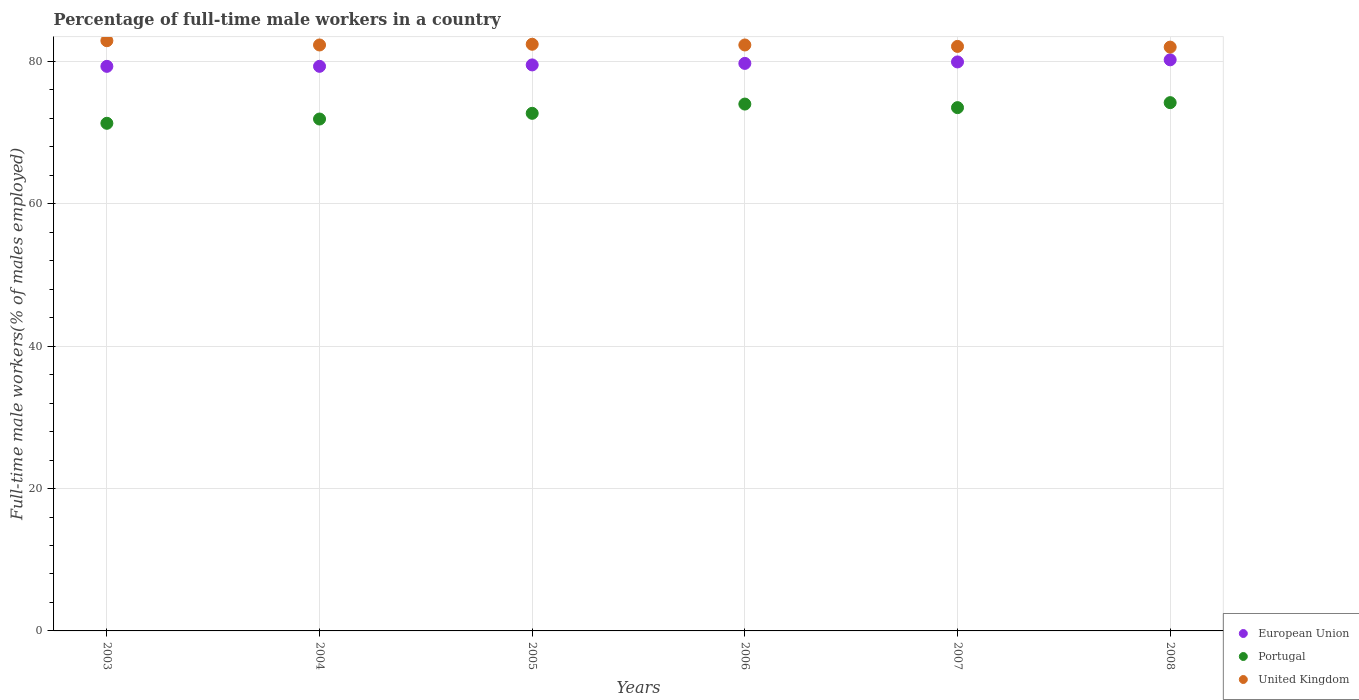What is the percentage of full-time male workers in European Union in 2006?
Give a very brief answer. 79.71. Across all years, what is the maximum percentage of full-time male workers in United Kingdom?
Your answer should be very brief. 82.9. Across all years, what is the minimum percentage of full-time male workers in European Union?
Give a very brief answer. 79.3. In which year was the percentage of full-time male workers in United Kingdom maximum?
Give a very brief answer. 2003. In which year was the percentage of full-time male workers in Portugal minimum?
Your response must be concise. 2003. What is the total percentage of full-time male workers in United Kingdom in the graph?
Provide a short and direct response. 494. What is the difference between the percentage of full-time male workers in United Kingdom in 2003 and that in 2006?
Ensure brevity in your answer.  0.6. What is the difference between the percentage of full-time male workers in United Kingdom in 2006 and the percentage of full-time male workers in Portugal in 2005?
Make the answer very short. 9.6. What is the average percentage of full-time male workers in European Union per year?
Keep it short and to the point. 79.66. In the year 2008, what is the difference between the percentage of full-time male workers in Portugal and percentage of full-time male workers in European Union?
Ensure brevity in your answer.  -6.01. What is the ratio of the percentage of full-time male workers in United Kingdom in 2005 to that in 2008?
Provide a short and direct response. 1. Is the percentage of full-time male workers in United Kingdom in 2003 less than that in 2005?
Your response must be concise. No. What is the difference between the highest and the second highest percentage of full-time male workers in United Kingdom?
Your response must be concise. 0.5. What is the difference between the highest and the lowest percentage of full-time male workers in United Kingdom?
Your answer should be compact. 0.9. In how many years, is the percentage of full-time male workers in European Union greater than the average percentage of full-time male workers in European Union taken over all years?
Offer a very short reply. 3. Is it the case that in every year, the sum of the percentage of full-time male workers in United Kingdom and percentage of full-time male workers in Portugal  is greater than the percentage of full-time male workers in European Union?
Make the answer very short. Yes. Does the percentage of full-time male workers in United Kingdom monotonically increase over the years?
Your answer should be compact. No. Is the percentage of full-time male workers in European Union strictly less than the percentage of full-time male workers in United Kingdom over the years?
Provide a succinct answer. Yes. How many dotlines are there?
Your response must be concise. 3. Where does the legend appear in the graph?
Keep it short and to the point. Bottom right. What is the title of the graph?
Your answer should be very brief. Percentage of full-time male workers in a country. Does "High income: OECD" appear as one of the legend labels in the graph?
Ensure brevity in your answer.  No. What is the label or title of the Y-axis?
Provide a succinct answer. Full-time male workers(% of males employed). What is the Full-time male workers(% of males employed) of European Union in 2003?
Offer a very short reply. 79.3. What is the Full-time male workers(% of males employed) in Portugal in 2003?
Give a very brief answer. 71.3. What is the Full-time male workers(% of males employed) in United Kingdom in 2003?
Ensure brevity in your answer.  82.9. What is the Full-time male workers(% of males employed) of European Union in 2004?
Offer a terse response. 79.3. What is the Full-time male workers(% of males employed) in Portugal in 2004?
Make the answer very short. 71.9. What is the Full-time male workers(% of males employed) of United Kingdom in 2004?
Provide a succinct answer. 82.3. What is the Full-time male workers(% of males employed) in European Union in 2005?
Ensure brevity in your answer.  79.5. What is the Full-time male workers(% of males employed) of Portugal in 2005?
Give a very brief answer. 72.7. What is the Full-time male workers(% of males employed) of United Kingdom in 2005?
Your answer should be compact. 82.4. What is the Full-time male workers(% of males employed) of European Union in 2006?
Keep it short and to the point. 79.71. What is the Full-time male workers(% of males employed) in United Kingdom in 2006?
Give a very brief answer. 82.3. What is the Full-time male workers(% of males employed) in European Union in 2007?
Keep it short and to the point. 79.92. What is the Full-time male workers(% of males employed) in Portugal in 2007?
Offer a terse response. 73.5. What is the Full-time male workers(% of males employed) in United Kingdom in 2007?
Provide a short and direct response. 82.1. What is the Full-time male workers(% of males employed) of European Union in 2008?
Your answer should be compact. 80.21. What is the Full-time male workers(% of males employed) of Portugal in 2008?
Your answer should be compact. 74.2. Across all years, what is the maximum Full-time male workers(% of males employed) in European Union?
Your answer should be compact. 80.21. Across all years, what is the maximum Full-time male workers(% of males employed) in Portugal?
Give a very brief answer. 74.2. Across all years, what is the maximum Full-time male workers(% of males employed) of United Kingdom?
Your answer should be compact. 82.9. Across all years, what is the minimum Full-time male workers(% of males employed) of European Union?
Your answer should be compact. 79.3. Across all years, what is the minimum Full-time male workers(% of males employed) in Portugal?
Ensure brevity in your answer.  71.3. What is the total Full-time male workers(% of males employed) of European Union in the graph?
Provide a succinct answer. 477.94. What is the total Full-time male workers(% of males employed) of Portugal in the graph?
Offer a very short reply. 437.6. What is the total Full-time male workers(% of males employed) of United Kingdom in the graph?
Offer a very short reply. 494. What is the difference between the Full-time male workers(% of males employed) in European Union in 2003 and that in 2004?
Ensure brevity in your answer.  -0. What is the difference between the Full-time male workers(% of males employed) in United Kingdom in 2003 and that in 2004?
Provide a succinct answer. 0.6. What is the difference between the Full-time male workers(% of males employed) of European Union in 2003 and that in 2005?
Your answer should be very brief. -0.2. What is the difference between the Full-time male workers(% of males employed) of European Union in 2003 and that in 2006?
Your answer should be very brief. -0.41. What is the difference between the Full-time male workers(% of males employed) of United Kingdom in 2003 and that in 2006?
Your answer should be very brief. 0.6. What is the difference between the Full-time male workers(% of males employed) in European Union in 2003 and that in 2007?
Keep it short and to the point. -0.62. What is the difference between the Full-time male workers(% of males employed) of Portugal in 2003 and that in 2007?
Offer a terse response. -2.2. What is the difference between the Full-time male workers(% of males employed) in European Union in 2003 and that in 2008?
Give a very brief answer. -0.92. What is the difference between the Full-time male workers(% of males employed) in United Kingdom in 2003 and that in 2008?
Keep it short and to the point. 0.9. What is the difference between the Full-time male workers(% of males employed) of European Union in 2004 and that in 2005?
Provide a short and direct response. -0.2. What is the difference between the Full-time male workers(% of males employed) of Portugal in 2004 and that in 2005?
Ensure brevity in your answer.  -0.8. What is the difference between the Full-time male workers(% of males employed) of United Kingdom in 2004 and that in 2005?
Provide a succinct answer. -0.1. What is the difference between the Full-time male workers(% of males employed) of European Union in 2004 and that in 2006?
Provide a succinct answer. -0.41. What is the difference between the Full-time male workers(% of males employed) in European Union in 2004 and that in 2007?
Offer a very short reply. -0.62. What is the difference between the Full-time male workers(% of males employed) in European Union in 2004 and that in 2008?
Provide a short and direct response. -0.91. What is the difference between the Full-time male workers(% of males employed) in European Union in 2005 and that in 2006?
Make the answer very short. -0.21. What is the difference between the Full-time male workers(% of males employed) in United Kingdom in 2005 and that in 2006?
Ensure brevity in your answer.  0.1. What is the difference between the Full-time male workers(% of males employed) of European Union in 2005 and that in 2007?
Give a very brief answer. -0.42. What is the difference between the Full-time male workers(% of males employed) of Portugal in 2005 and that in 2007?
Give a very brief answer. -0.8. What is the difference between the Full-time male workers(% of males employed) of European Union in 2005 and that in 2008?
Give a very brief answer. -0.71. What is the difference between the Full-time male workers(% of males employed) in European Union in 2006 and that in 2007?
Your answer should be compact. -0.21. What is the difference between the Full-time male workers(% of males employed) in United Kingdom in 2006 and that in 2007?
Ensure brevity in your answer.  0.2. What is the difference between the Full-time male workers(% of males employed) in European Union in 2006 and that in 2008?
Give a very brief answer. -0.5. What is the difference between the Full-time male workers(% of males employed) in European Union in 2007 and that in 2008?
Keep it short and to the point. -0.3. What is the difference between the Full-time male workers(% of males employed) of Portugal in 2007 and that in 2008?
Keep it short and to the point. -0.7. What is the difference between the Full-time male workers(% of males employed) in United Kingdom in 2007 and that in 2008?
Make the answer very short. 0.1. What is the difference between the Full-time male workers(% of males employed) in European Union in 2003 and the Full-time male workers(% of males employed) in Portugal in 2004?
Provide a short and direct response. 7.4. What is the difference between the Full-time male workers(% of males employed) of European Union in 2003 and the Full-time male workers(% of males employed) of United Kingdom in 2004?
Ensure brevity in your answer.  -3. What is the difference between the Full-time male workers(% of males employed) in Portugal in 2003 and the Full-time male workers(% of males employed) in United Kingdom in 2004?
Your answer should be very brief. -11. What is the difference between the Full-time male workers(% of males employed) of European Union in 2003 and the Full-time male workers(% of males employed) of Portugal in 2005?
Provide a short and direct response. 6.6. What is the difference between the Full-time male workers(% of males employed) of European Union in 2003 and the Full-time male workers(% of males employed) of United Kingdom in 2005?
Offer a very short reply. -3.1. What is the difference between the Full-time male workers(% of males employed) of European Union in 2003 and the Full-time male workers(% of males employed) of Portugal in 2006?
Offer a very short reply. 5.3. What is the difference between the Full-time male workers(% of males employed) in European Union in 2003 and the Full-time male workers(% of males employed) in United Kingdom in 2006?
Keep it short and to the point. -3. What is the difference between the Full-time male workers(% of males employed) of European Union in 2003 and the Full-time male workers(% of males employed) of Portugal in 2007?
Keep it short and to the point. 5.8. What is the difference between the Full-time male workers(% of males employed) in European Union in 2003 and the Full-time male workers(% of males employed) in United Kingdom in 2007?
Keep it short and to the point. -2.8. What is the difference between the Full-time male workers(% of males employed) of Portugal in 2003 and the Full-time male workers(% of males employed) of United Kingdom in 2007?
Offer a terse response. -10.8. What is the difference between the Full-time male workers(% of males employed) in European Union in 2003 and the Full-time male workers(% of males employed) in Portugal in 2008?
Provide a succinct answer. 5.1. What is the difference between the Full-time male workers(% of males employed) of European Union in 2003 and the Full-time male workers(% of males employed) of United Kingdom in 2008?
Offer a very short reply. -2.7. What is the difference between the Full-time male workers(% of males employed) in Portugal in 2003 and the Full-time male workers(% of males employed) in United Kingdom in 2008?
Make the answer very short. -10.7. What is the difference between the Full-time male workers(% of males employed) in European Union in 2004 and the Full-time male workers(% of males employed) in Portugal in 2005?
Provide a succinct answer. 6.6. What is the difference between the Full-time male workers(% of males employed) of European Union in 2004 and the Full-time male workers(% of males employed) of United Kingdom in 2005?
Offer a terse response. -3.1. What is the difference between the Full-time male workers(% of males employed) of European Union in 2004 and the Full-time male workers(% of males employed) of Portugal in 2006?
Your answer should be very brief. 5.3. What is the difference between the Full-time male workers(% of males employed) of European Union in 2004 and the Full-time male workers(% of males employed) of United Kingdom in 2006?
Keep it short and to the point. -3. What is the difference between the Full-time male workers(% of males employed) in Portugal in 2004 and the Full-time male workers(% of males employed) in United Kingdom in 2006?
Your response must be concise. -10.4. What is the difference between the Full-time male workers(% of males employed) of European Union in 2004 and the Full-time male workers(% of males employed) of Portugal in 2007?
Make the answer very short. 5.8. What is the difference between the Full-time male workers(% of males employed) of European Union in 2004 and the Full-time male workers(% of males employed) of United Kingdom in 2007?
Provide a short and direct response. -2.8. What is the difference between the Full-time male workers(% of males employed) of Portugal in 2004 and the Full-time male workers(% of males employed) of United Kingdom in 2007?
Keep it short and to the point. -10.2. What is the difference between the Full-time male workers(% of males employed) of European Union in 2004 and the Full-time male workers(% of males employed) of Portugal in 2008?
Make the answer very short. 5.1. What is the difference between the Full-time male workers(% of males employed) in European Union in 2004 and the Full-time male workers(% of males employed) in United Kingdom in 2008?
Provide a succinct answer. -2.7. What is the difference between the Full-time male workers(% of males employed) in Portugal in 2004 and the Full-time male workers(% of males employed) in United Kingdom in 2008?
Provide a short and direct response. -10.1. What is the difference between the Full-time male workers(% of males employed) of European Union in 2005 and the Full-time male workers(% of males employed) of Portugal in 2006?
Make the answer very short. 5.5. What is the difference between the Full-time male workers(% of males employed) of European Union in 2005 and the Full-time male workers(% of males employed) of United Kingdom in 2006?
Your answer should be compact. -2.8. What is the difference between the Full-time male workers(% of males employed) of European Union in 2005 and the Full-time male workers(% of males employed) of Portugal in 2007?
Offer a very short reply. 6. What is the difference between the Full-time male workers(% of males employed) of European Union in 2005 and the Full-time male workers(% of males employed) of United Kingdom in 2007?
Provide a succinct answer. -2.6. What is the difference between the Full-time male workers(% of males employed) of Portugal in 2005 and the Full-time male workers(% of males employed) of United Kingdom in 2007?
Your answer should be compact. -9.4. What is the difference between the Full-time male workers(% of males employed) of European Union in 2005 and the Full-time male workers(% of males employed) of Portugal in 2008?
Your response must be concise. 5.3. What is the difference between the Full-time male workers(% of males employed) in European Union in 2005 and the Full-time male workers(% of males employed) in United Kingdom in 2008?
Make the answer very short. -2.5. What is the difference between the Full-time male workers(% of males employed) in Portugal in 2005 and the Full-time male workers(% of males employed) in United Kingdom in 2008?
Provide a succinct answer. -9.3. What is the difference between the Full-time male workers(% of males employed) of European Union in 2006 and the Full-time male workers(% of males employed) of Portugal in 2007?
Your answer should be compact. 6.21. What is the difference between the Full-time male workers(% of males employed) of European Union in 2006 and the Full-time male workers(% of males employed) of United Kingdom in 2007?
Your answer should be compact. -2.39. What is the difference between the Full-time male workers(% of males employed) of European Union in 2006 and the Full-time male workers(% of males employed) of Portugal in 2008?
Offer a terse response. 5.51. What is the difference between the Full-time male workers(% of males employed) in European Union in 2006 and the Full-time male workers(% of males employed) in United Kingdom in 2008?
Your answer should be compact. -2.29. What is the difference between the Full-time male workers(% of males employed) in Portugal in 2006 and the Full-time male workers(% of males employed) in United Kingdom in 2008?
Offer a terse response. -8. What is the difference between the Full-time male workers(% of males employed) in European Union in 2007 and the Full-time male workers(% of males employed) in Portugal in 2008?
Offer a very short reply. 5.72. What is the difference between the Full-time male workers(% of males employed) of European Union in 2007 and the Full-time male workers(% of males employed) of United Kingdom in 2008?
Ensure brevity in your answer.  -2.08. What is the average Full-time male workers(% of males employed) in European Union per year?
Provide a succinct answer. 79.66. What is the average Full-time male workers(% of males employed) in Portugal per year?
Offer a terse response. 72.93. What is the average Full-time male workers(% of males employed) in United Kingdom per year?
Offer a very short reply. 82.33. In the year 2003, what is the difference between the Full-time male workers(% of males employed) in European Union and Full-time male workers(% of males employed) in Portugal?
Provide a short and direct response. 8. In the year 2003, what is the difference between the Full-time male workers(% of males employed) in European Union and Full-time male workers(% of males employed) in United Kingdom?
Your answer should be compact. -3.6. In the year 2004, what is the difference between the Full-time male workers(% of males employed) in European Union and Full-time male workers(% of males employed) in Portugal?
Ensure brevity in your answer.  7.4. In the year 2004, what is the difference between the Full-time male workers(% of males employed) of European Union and Full-time male workers(% of males employed) of United Kingdom?
Provide a short and direct response. -3. In the year 2005, what is the difference between the Full-time male workers(% of males employed) of European Union and Full-time male workers(% of males employed) of Portugal?
Provide a short and direct response. 6.8. In the year 2005, what is the difference between the Full-time male workers(% of males employed) in European Union and Full-time male workers(% of males employed) in United Kingdom?
Provide a succinct answer. -2.9. In the year 2005, what is the difference between the Full-time male workers(% of males employed) in Portugal and Full-time male workers(% of males employed) in United Kingdom?
Keep it short and to the point. -9.7. In the year 2006, what is the difference between the Full-time male workers(% of males employed) of European Union and Full-time male workers(% of males employed) of Portugal?
Your response must be concise. 5.71. In the year 2006, what is the difference between the Full-time male workers(% of males employed) in European Union and Full-time male workers(% of males employed) in United Kingdom?
Provide a succinct answer. -2.59. In the year 2007, what is the difference between the Full-time male workers(% of males employed) of European Union and Full-time male workers(% of males employed) of Portugal?
Give a very brief answer. 6.42. In the year 2007, what is the difference between the Full-time male workers(% of males employed) of European Union and Full-time male workers(% of males employed) of United Kingdom?
Provide a succinct answer. -2.18. In the year 2008, what is the difference between the Full-time male workers(% of males employed) in European Union and Full-time male workers(% of males employed) in Portugal?
Offer a very short reply. 6.01. In the year 2008, what is the difference between the Full-time male workers(% of males employed) of European Union and Full-time male workers(% of males employed) of United Kingdom?
Provide a short and direct response. -1.79. What is the ratio of the Full-time male workers(% of males employed) in Portugal in 2003 to that in 2004?
Give a very brief answer. 0.99. What is the ratio of the Full-time male workers(% of males employed) in United Kingdom in 2003 to that in 2004?
Offer a terse response. 1.01. What is the ratio of the Full-time male workers(% of males employed) in European Union in 2003 to that in 2005?
Provide a short and direct response. 1. What is the ratio of the Full-time male workers(% of males employed) of Portugal in 2003 to that in 2005?
Ensure brevity in your answer.  0.98. What is the ratio of the Full-time male workers(% of males employed) of United Kingdom in 2003 to that in 2005?
Your answer should be very brief. 1.01. What is the ratio of the Full-time male workers(% of males employed) of European Union in 2003 to that in 2006?
Your answer should be compact. 0.99. What is the ratio of the Full-time male workers(% of males employed) in Portugal in 2003 to that in 2006?
Provide a succinct answer. 0.96. What is the ratio of the Full-time male workers(% of males employed) in United Kingdom in 2003 to that in 2006?
Provide a succinct answer. 1.01. What is the ratio of the Full-time male workers(% of males employed) in European Union in 2003 to that in 2007?
Provide a short and direct response. 0.99. What is the ratio of the Full-time male workers(% of males employed) in Portugal in 2003 to that in 2007?
Offer a terse response. 0.97. What is the ratio of the Full-time male workers(% of males employed) in United Kingdom in 2003 to that in 2007?
Your response must be concise. 1.01. What is the ratio of the Full-time male workers(% of males employed) of Portugal in 2003 to that in 2008?
Ensure brevity in your answer.  0.96. What is the ratio of the Full-time male workers(% of males employed) in European Union in 2004 to that in 2005?
Offer a terse response. 1. What is the ratio of the Full-time male workers(% of males employed) of Portugal in 2004 to that in 2005?
Your response must be concise. 0.99. What is the ratio of the Full-time male workers(% of males employed) of Portugal in 2004 to that in 2006?
Make the answer very short. 0.97. What is the ratio of the Full-time male workers(% of males employed) in European Union in 2004 to that in 2007?
Offer a very short reply. 0.99. What is the ratio of the Full-time male workers(% of males employed) of Portugal in 2004 to that in 2007?
Provide a succinct answer. 0.98. What is the ratio of the Full-time male workers(% of males employed) of United Kingdom in 2004 to that in 2007?
Your answer should be very brief. 1. What is the ratio of the Full-time male workers(% of males employed) in European Union in 2004 to that in 2008?
Keep it short and to the point. 0.99. What is the ratio of the Full-time male workers(% of males employed) of Portugal in 2004 to that in 2008?
Ensure brevity in your answer.  0.97. What is the ratio of the Full-time male workers(% of males employed) of European Union in 2005 to that in 2006?
Offer a terse response. 1. What is the ratio of the Full-time male workers(% of males employed) in Portugal in 2005 to that in 2006?
Ensure brevity in your answer.  0.98. What is the ratio of the Full-time male workers(% of males employed) of United Kingdom in 2005 to that in 2006?
Your answer should be compact. 1. What is the ratio of the Full-time male workers(% of males employed) of Portugal in 2005 to that in 2007?
Provide a succinct answer. 0.99. What is the ratio of the Full-time male workers(% of males employed) of Portugal in 2005 to that in 2008?
Your answer should be compact. 0.98. What is the ratio of the Full-time male workers(% of males employed) in United Kingdom in 2005 to that in 2008?
Give a very brief answer. 1. What is the ratio of the Full-time male workers(% of males employed) of Portugal in 2006 to that in 2007?
Your answer should be compact. 1.01. What is the ratio of the Full-time male workers(% of males employed) of United Kingdom in 2006 to that in 2008?
Offer a terse response. 1. What is the ratio of the Full-time male workers(% of males employed) in Portugal in 2007 to that in 2008?
Offer a terse response. 0.99. What is the difference between the highest and the second highest Full-time male workers(% of males employed) in European Union?
Ensure brevity in your answer.  0.3. What is the difference between the highest and the second highest Full-time male workers(% of males employed) in Portugal?
Offer a terse response. 0.2. What is the difference between the highest and the lowest Full-time male workers(% of males employed) of European Union?
Your answer should be compact. 0.92. What is the difference between the highest and the lowest Full-time male workers(% of males employed) of United Kingdom?
Keep it short and to the point. 0.9. 